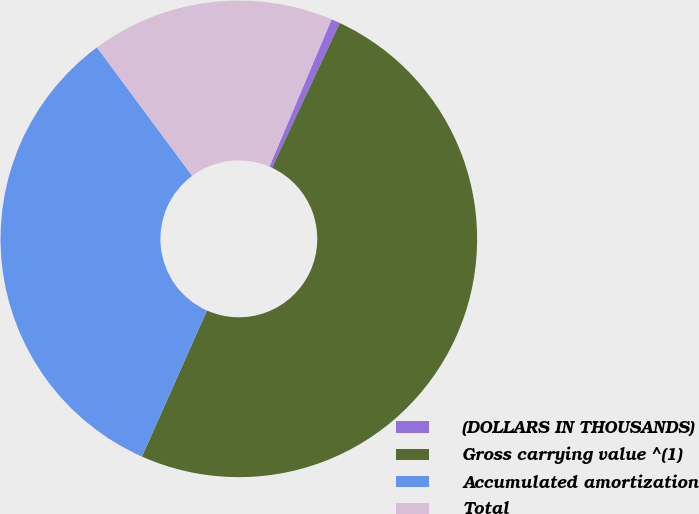Convert chart. <chart><loc_0><loc_0><loc_500><loc_500><pie_chart><fcel>(DOLLARS IN THOUSANDS)<fcel>Gross carrying value ^(1)<fcel>Accumulated amortization<fcel>Total<nl><fcel>0.6%<fcel>49.7%<fcel>33.19%<fcel>16.51%<nl></chart> 